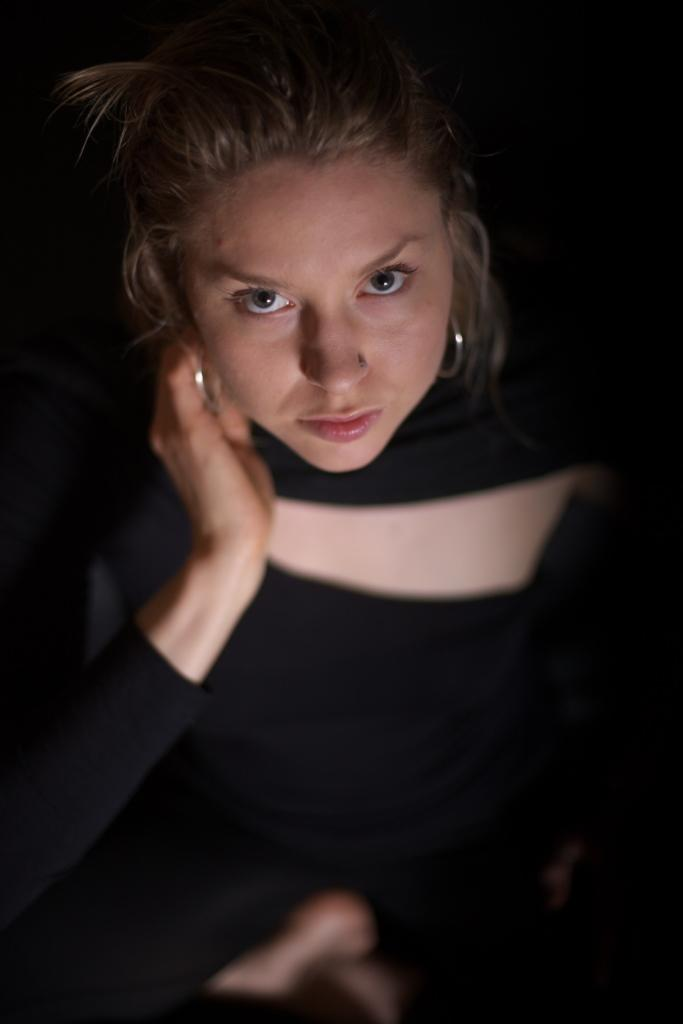Who is the main subject in the image? There is a lady in the image. What is the lady wearing in the image? The lady is wearing a black dress and silver color earrings. What time is the fireman shown in the image? There is no fireman present in the image, and therefore no time can be associated with one. 